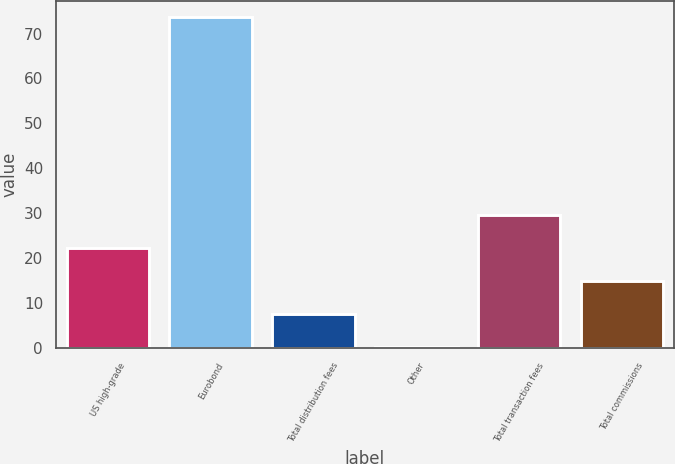Convert chart. <chart><loc_0><loc_0><loc_500><loc_500><bar_chart><fcel>US high-grade<fcel>Eurobond<fcel>Total distribution fees<fcel>Other<fcel>Total transaction fees<fcel>Total commissions<nl><fcel>22.15<fcel>73.6<fcel>7.45<fcel>0.1<fcel>29.5<fcel>14.8<nl></chart> 